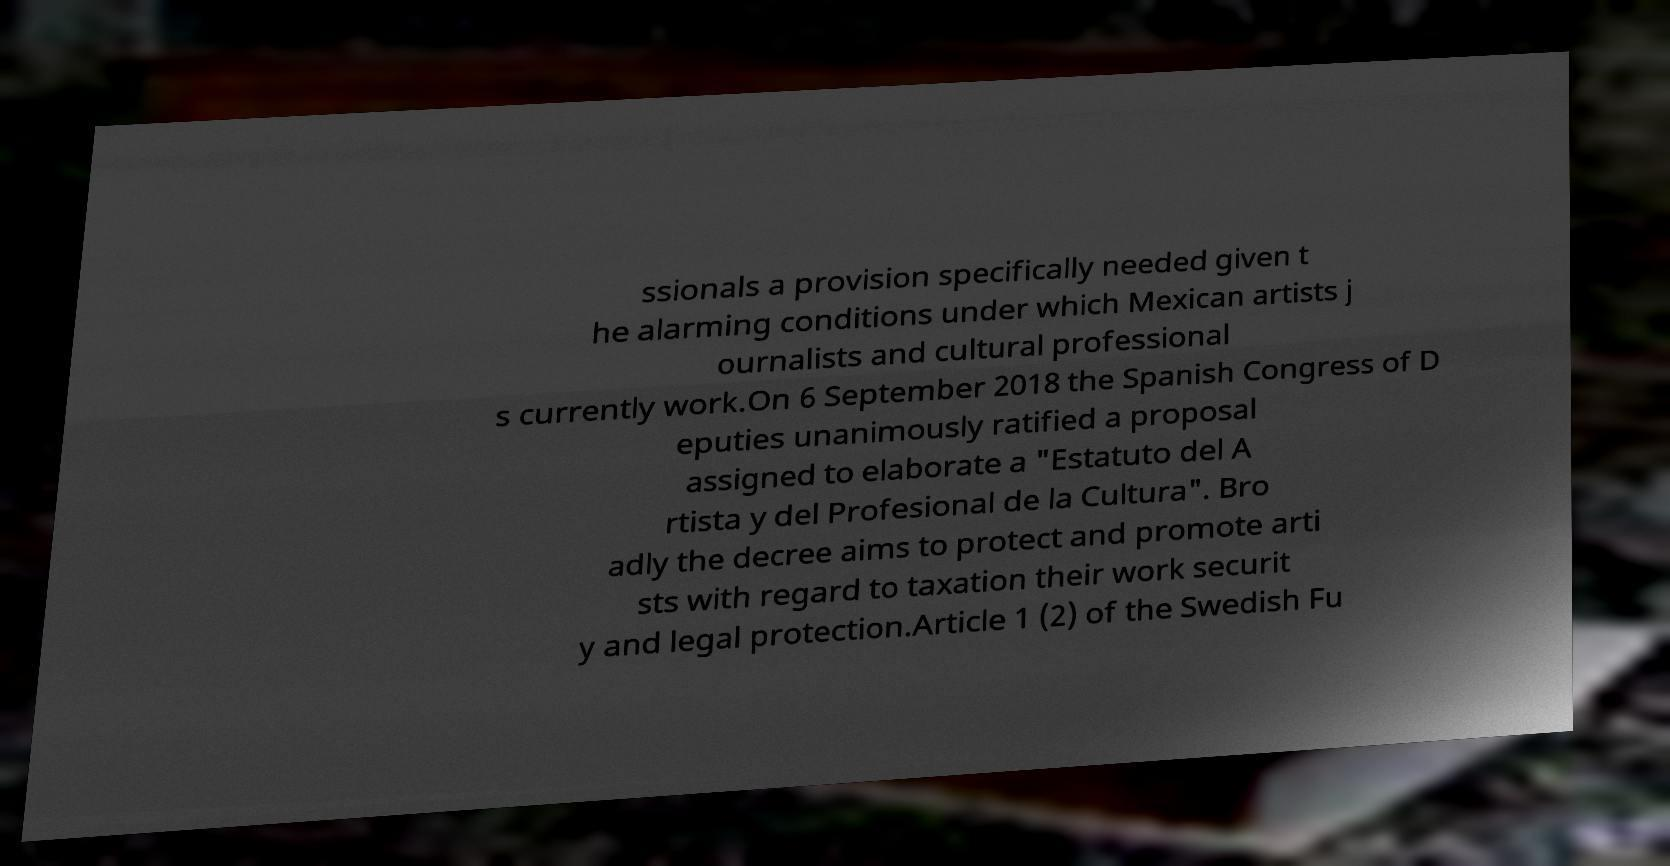Please identify and transcribe the text found in this image. ssionals a provision specifically needed given t he alarming conditions under which Mexican artists j ournalists and cultural professional s currently work.On 6 September 2018 the Spanish Congress of D eputies unanimously ratified a proposal assigned to elaborate a "Estatuto del A rtista y del Profesional de la Cultura". Bro adly the decree aims to protect and promote arti sts with regard to taxation their work securit y and legal protection.Article 1 (2) of the Swedish Fu 